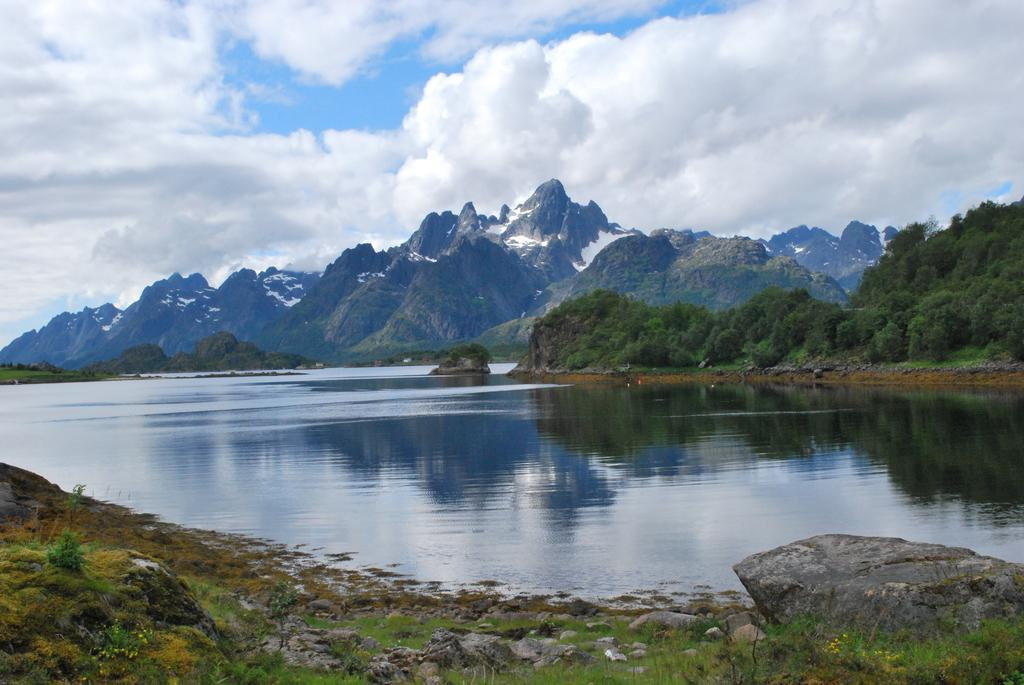What is located in the middle of the image? There is water in the middle of the image. What type of natural features can be seen in the image? There are trees and mountains in the image. What is visible at the top of the image? The sky is visible at the top of the image. Can you see a monkey blowing bubbles with a faucet in the image? No, there is no monkey or faucet present in the image. 